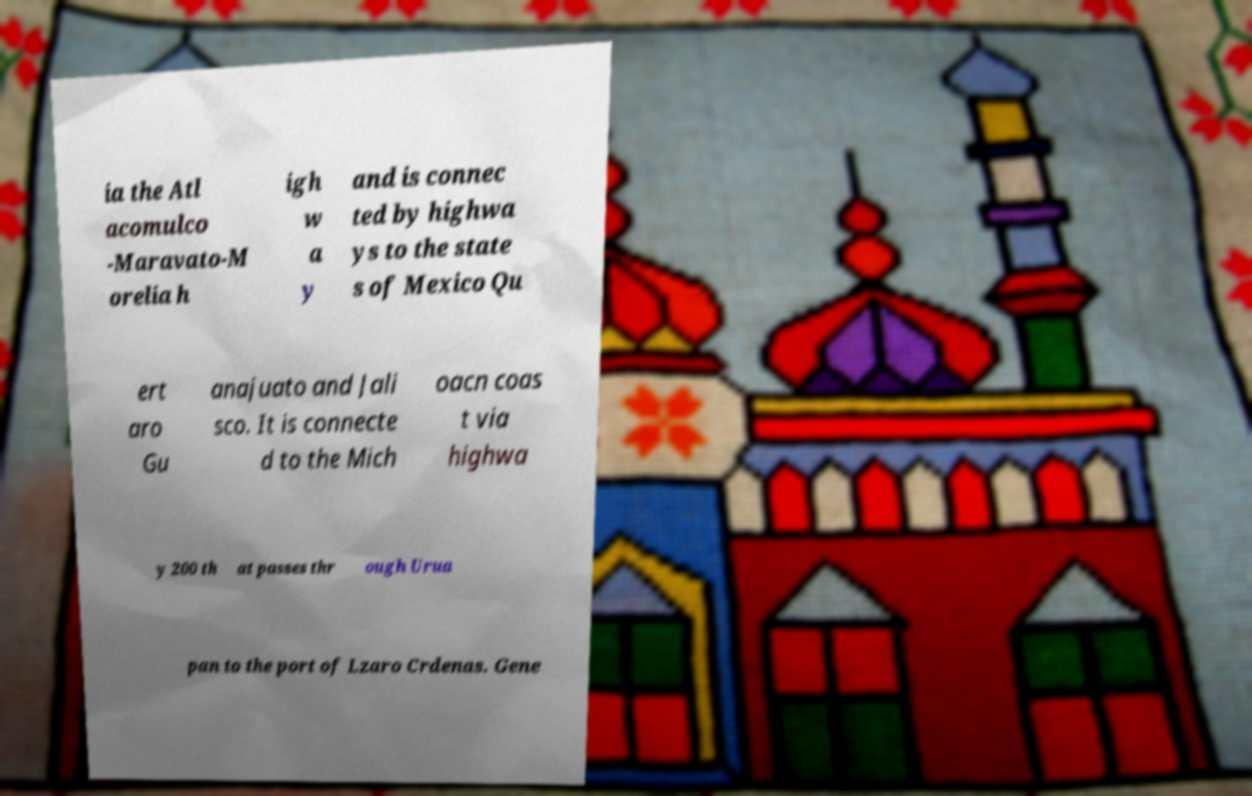For documentation purposes, I need the text within this image transcribed. Could you provide that? ia the Atl acomulco -Maravato-M orelia h igh w a y and is connec ted by highwa ys to the state s of Mexico Qu ert aro Gu anajuato and Jali sco. It is connecte d to the Mich oacn coas t via highwa y 200 th at passes thr ough Urua pan to the port of Lzaro Crdenas. Gene 